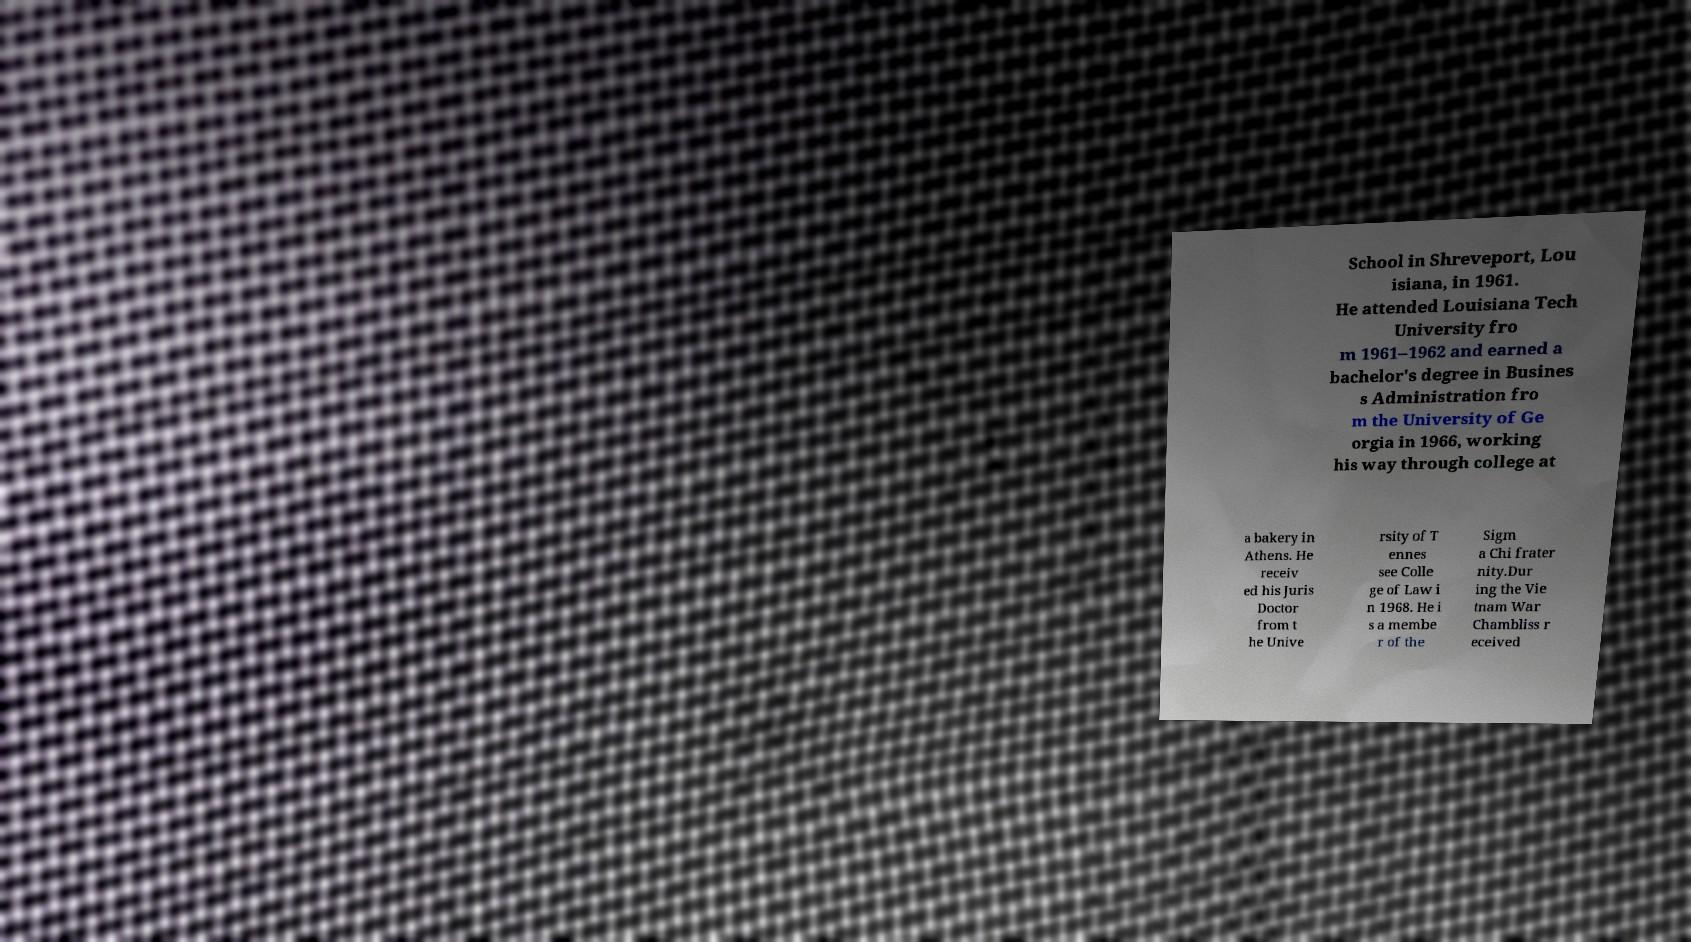Could you extract and type out the text from this image? School in Shreveport, Lou isiana, in 1961. He attended Louisiana Tech University fro m 1961–1962 and earned a bachelor's degree in Busines s Administration fro m the University of Ge orgia in 1966, working his way through college at a bakery in Athens. He receiv ed his Juris Doctor from t he Unive rsity of T ennes see Colle ge of Law i n 1968. He i s a membe r of the Sigm a Chi frater nity.Dur ing the Vie tnam War Chambliss r eceived 